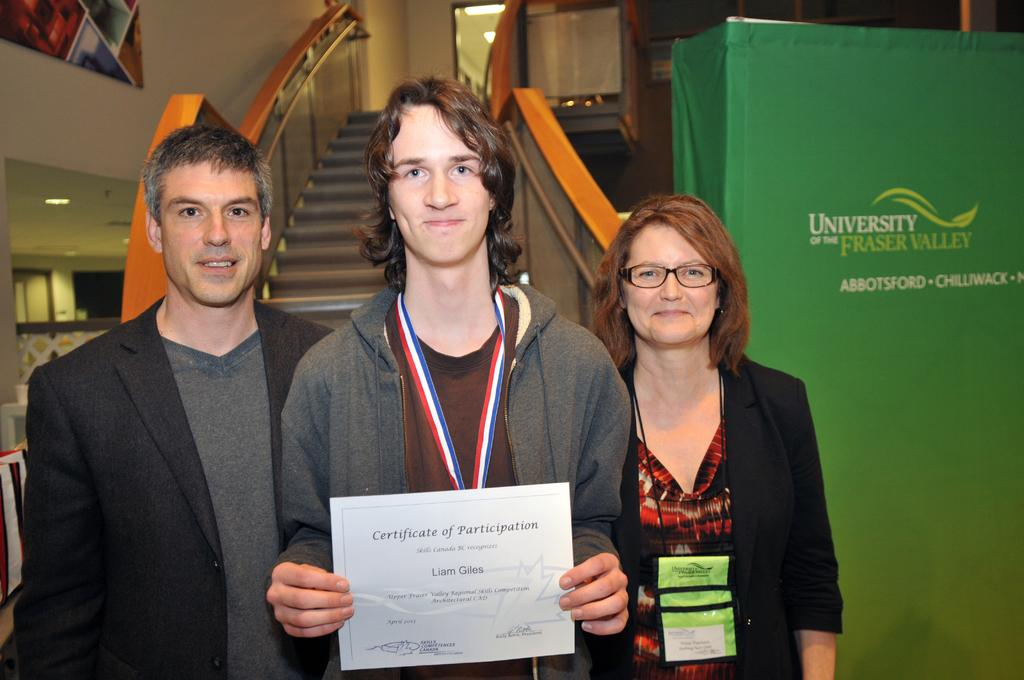<image>
Offer a succinct explanation of the picture presented. A young man proudly posees with his family and his certificate of participation at the University of the Fraser Valley 